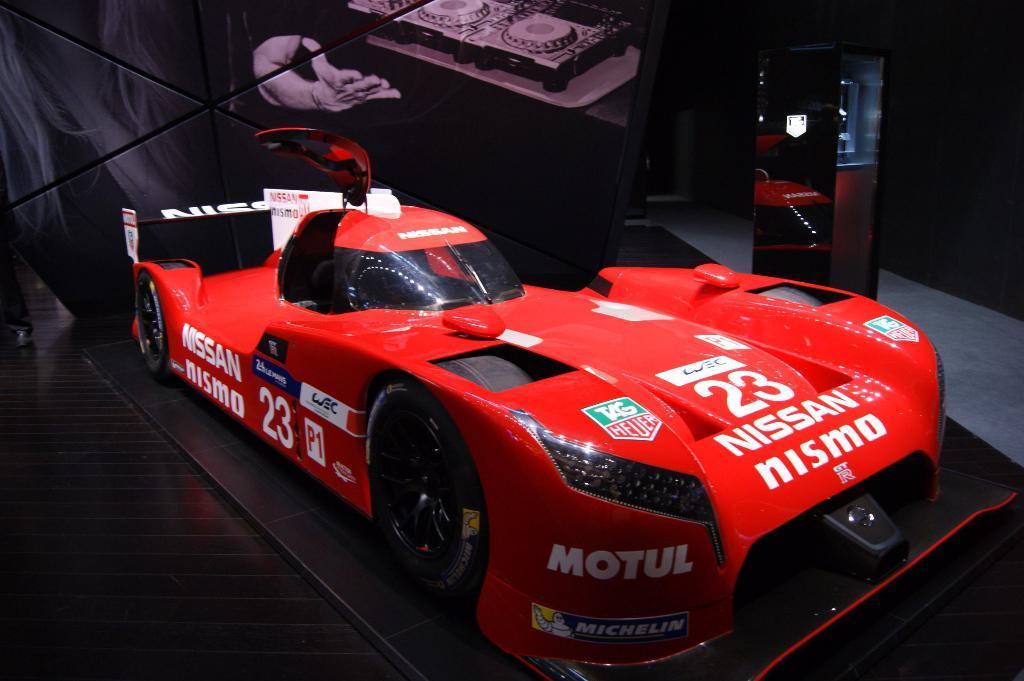How would you summarize this image in a sentence or two? In this image in the front there is a car which is red in colour with some text written on it. In the background there is a curtain with some drawing and there is an object which is black in colour. On the left side there is a person which is visible. 